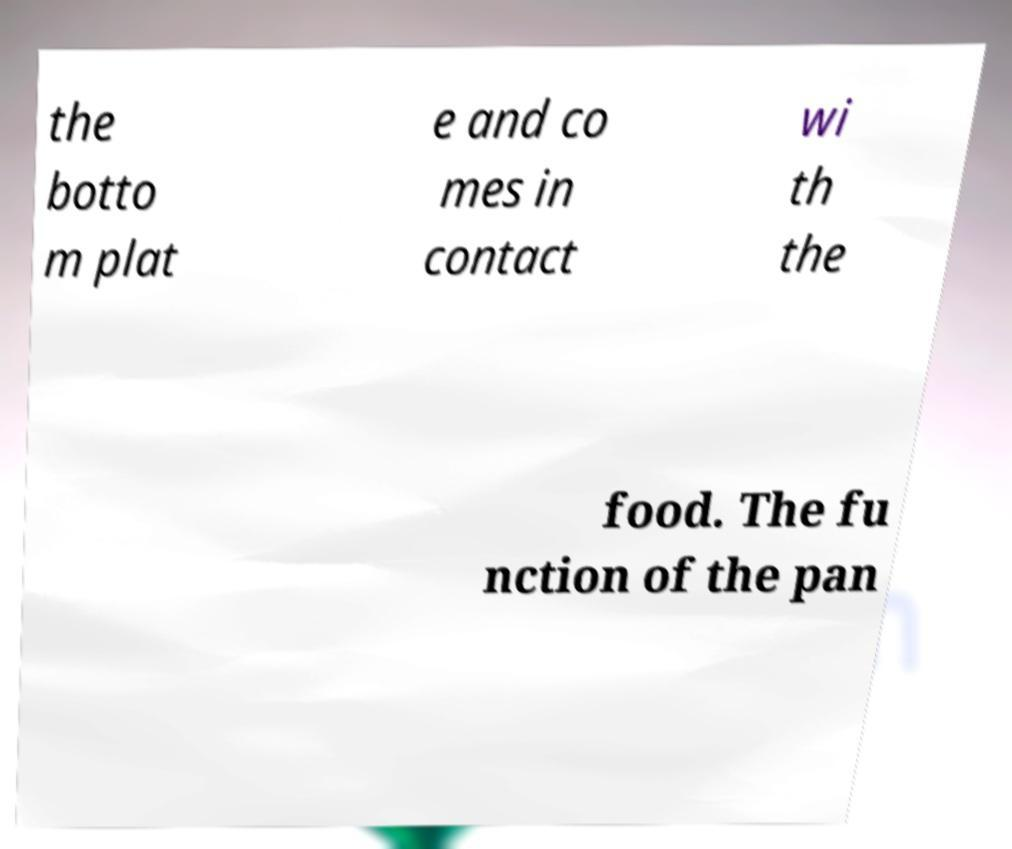Can you accurately transcribe the text from the provided image for me? the botto m plat e and co mes in contact wi th the food. The fu nction of the pan 